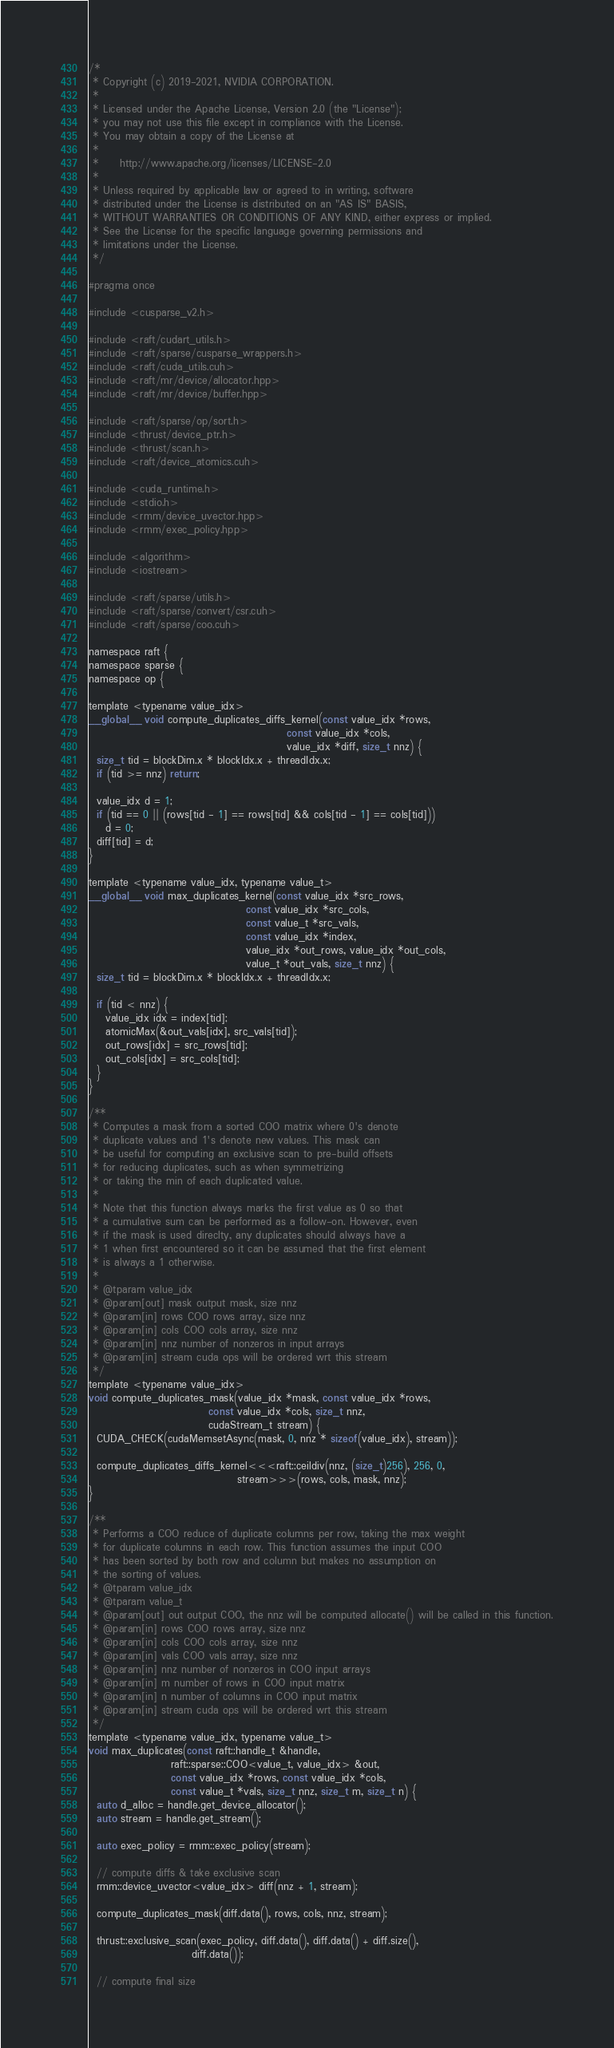Convert code to text. <code><loc_0><loc_0><loc_500><loc_500><_Cuda_>/*
 * Copyright (c) 2019-2021, NVIDIA CORPORATION.
 *
 * Licensed under the Apache License, Version 2.0 (the "License");
 * you may not use this file except in compliance with the License.
 * You may obtain a copy of the License at
 *
 *     http://www.apache.org/licenses/LICENSE-2.0
 *
 * Unless required by applicable law or agreed to in writing, software
 * distributed under the License is distributed on an "AS IS" BASIS,
 * WITHOUT WARRANTIES OR CONDITIONS OF ANY KIND, either express or implied.
 * See the License for the specific language governing permissions and
 * limitations under the License.
 */

#pragma once

#include <cusparse_v2.h>

#include <raft/cudart_utils.h>
#include <raft/sparse/cusparse_wrappers.h>
#include <raft/cuda_utils.cuh>
#include <raft/mr/device/allocator.hpp>
#include <raft/mr/device/buffer.hpp>

#include <raft/sparse/op/sort.h>
#include <thrust/device_ptr.h>
#include <thrust/scan.h>
#include <raft/device_atomics.cuh>

#include <cuda_runtime.h>
#include <stdio.h>
#include <rmm/device_uvector.hpp>
#include <rmm/exec_policy.hpp>

#include <algorithm>
#include <iostream>

#include <raft/sparse/utils.h>
#include <raft/sparse/convert/csr.cuh>
#include <raft/sparse/coo.cuh>

namespace raft {
namespace sparse {
namespace op {

template <typename value_idx>
__global__ void compute_duplicates_diffs_kernel(const value_idx *rows,
                                                const value_idx *cols,
                                                value_idx *diff, size_t nnz) {
  size_t tid = blockDim.x * blockIdx.x + threadIdx.x;
  if (tid >= nnz) return;

  value_idx d = 1;
  if (tid == 0 || (rows[tid - 1] == rows[tid] && cols[tid - 1] == cols[tid]))
    d = 0;
  diff[tid] = d;
}

template <typename value_idx, typename value_t>
__global__ void max_duplicates_kernel(const value_idx *src_rows,
                                      const value_idx *src_cols,
                                      const value_t *src_vals,
                                      const value_idx *index,
                                      value_idx *out_rows, value_idx *out_cols,
                                      value_t *out_vals, size_t nnz) {
  size_t tid = blockDim.x * blockIdx.x + threadIdx.x;

  if (tid < nnz) {
    value_idx idx = index[tid];
    atomicMax(&out_vals[idx], src_vals[tid]);
    out_rows[idx] = src_rows[tid];
    out_cols[idx] = src_cols[tid];
  }
}

/**
 * Computes a mask from a sorted COO matrix where 0's denote
 * duplicate values and 1's denote new values. This mask can
 * be useful for computing an exclusive scan to pre-build offsets
 * for reducing duplicates, such as when symmetrizing
 * or taking the min of each duplicated value.
 *
 * Note that this function always marks the first value as 0 so that
 * a cumulative sum can be performed as a follow-on. However, even
 * if the mask is used direclty, any duplicates should always have a
 * 1 when first encountered so it can be assumed that the first element
 * is always a 1 otherwise.
 *
 * @tparam value_idx
 * @param[out] mask output mask, size nnz
 * @param[in] rows COO rows array, size nnz
 * @param[in] cols COO cols array, size nnz
 * @param[in] nnz number of nonzeros in input arrays
 * @param[in] stream cuda ops will be ordered wrt this stream
 */
template <typename value_idx>
void compute_duplicates_mask(value_idx *mask, const value_idx *rows,
                             const value_idx *cols, size_t nnz,
                             cudaStream_t stream) {
  CUDA_CHECK(cudaMemsetAsync(mask, 0, nnz * sizeof(value_idx), stream));

  compute_duplicates_diffs_kernel<<<raft::ceildiv(nnz, (size_t)256), 256, 0,
                                    stream>>>(rows, cols, mask, nnz);
}

/**
 * Performs a COO reduce of duplicate columns per row, taking the max weight
 * for duplicate columns in each row. This function assumes the input COO
 * has been sorted by both row and column but makes no assumption on
 * the sorting of values.
 * @tparam value_idx
 * @tparam value_t
 * @param[out] out output COO, the nnz will be computed allocate() will be called in this function.
 * @param[in] rows COO rows array, size nnz
 * @param[in] cols COO cols array, size nnz
 * @param[in] vals COO vals array, size nnz
 * @param[in] nnz number of nonzeros in COO input arrays
 * @param[in] m number of rows in COO input matrix
 * @param[in] n number of columns in COO input matrix
 * @param[in] stream cuda ops will be ordered wrt this stream
 */
template <typename value_idx, typename value_t>
void max_duplicates(const raft::handle_t &handle,
                    raft::sparse::COO<value_t, value_idx> &out,
                    const value_idx *rows, const value_idx *cols,
                    const value_t *vals, size_t nnz, size_t m, size_t n) {
  auto d_alloc = handle.get_device_allocator();
  auto stream = handle.get_stream();

  auto exec_policy = rmm::exec_policy(stream);

  // compute diffs & take exclusive scan
  rmm::device_uvector<value_idx> diff(nnz + 1, stream);

  compute_duplicates_mask(diff.data(), rows, cols, nnz, stream);

  thrust::exclusive_scan(exec_policy, diff.data(), diff.data() + diff.size(),
                         diff.data());

  // compute final size</code> 